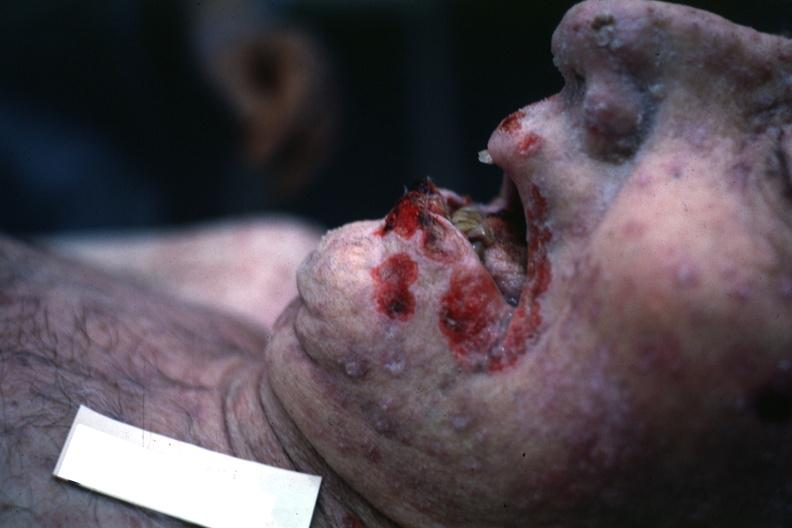what is present?
Answer the question using a single word or phrase. Herpes labialis 